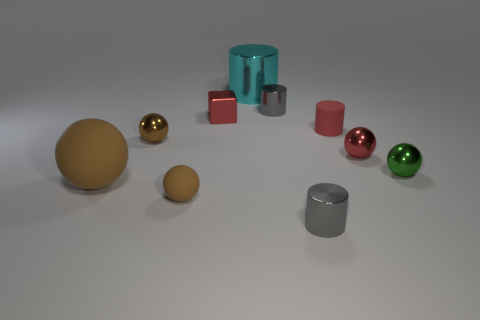How many brown balls must be subtracted to get 1 brown balls? 2 Subtract all cyan cylinders. How many brown spheres are left? 3 Subtract all red balls. How many balls are left? 4 Subtract all green metallic spheres. How many spheres are left? 4 Subtract 1 balls. How many balls are left? 4 Subtract all cyan spheres. Subtract all gray cylinders. How many spheres are left? 5 Subtract all cubes. How many objects are left? 9 Add 7 green metal spheres. How many green metal spheres exist? 8 Subtract 0 gray cubes. How many objects are left? 10 Subtract all red things. Subtract all small gray things. How many objects are left? 5 